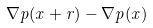Convert formula to latex. <formula><loc_0><loc_0><loc_500><loc_500>\nabla p ( x + r ) - \nabla p ( x )</formula> 